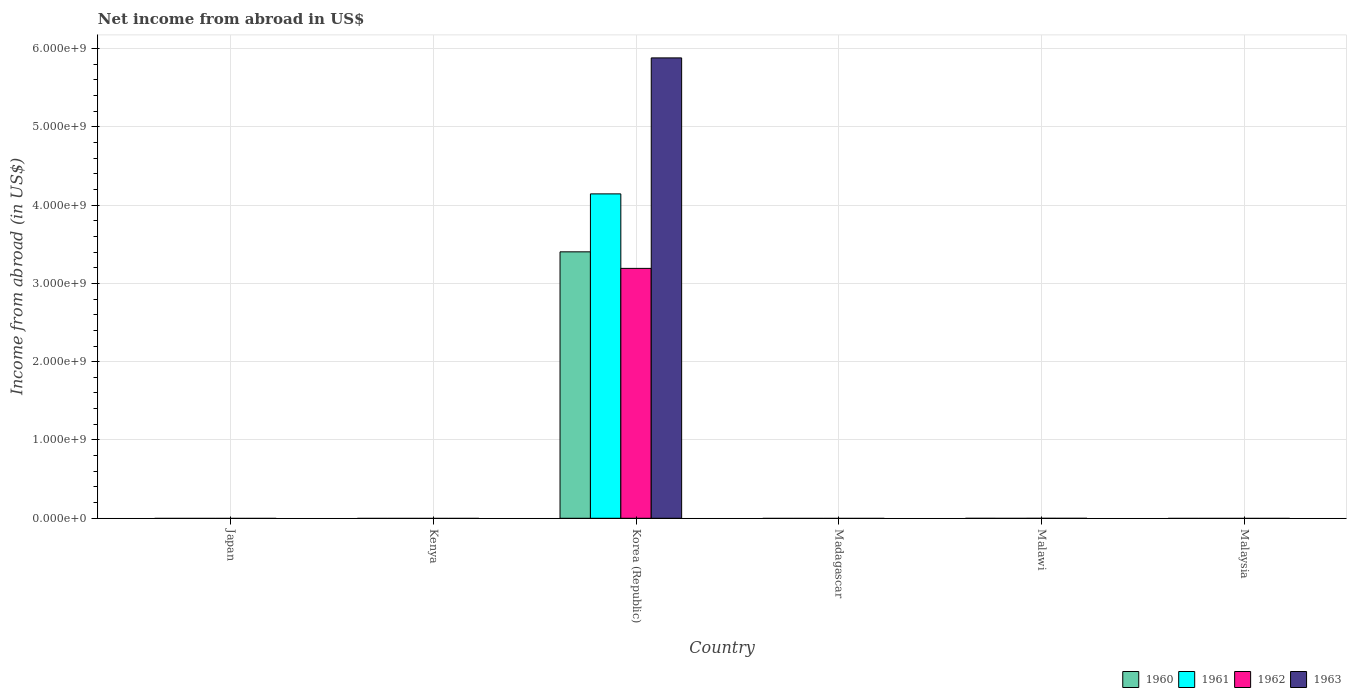How many different coloured bars are there?
Offer a terse response. 4. Are the number of bars on each tick of the X-axis equal?
Keep it short and to the point. No. How many bars are there on the 2nd tick from the left?
Your answer should be very brief. 0. How many bars are there on the 4th tick from the right?
Your response must be concise. 4. In how many cases, is the number of bars for a given country not equal to the number of legend labels?
Offer a very short reply. 5. What is the net income from abroad in 1961 in Madagascar?
Ensure brevity in your answer.  0. Across all countries, what is the maximum net income from abroad in 1961?
Your answer should be very brief. 4.14e+09. Across all countries, what is the minimum net income from abroad in 1960?
Your response must be concise. 0. What is the total net income from abroad in 1963 in the graph?
Offer a very short reply. 5.88e+09. What is the difference between the net income from abroad in 1962 in Japan and the net income from abroad in 1963 in Korea (Republic)?
Offer a terse response. -5.88e+09. What is the average net income from abroad in 1960 per country?
Your answer should be very brief. 5.67e+08. What is the difference between the net income from abroad of/in 1962 and net income from abroad of/in 1960 in Korea (Republic)?
Offer a terse response. -2.11e+08. In how many countries, is the net income from abroad in 1960 greater than 5400000000 US$?
Keep it short and to the point. 0. What is the difference between the highest and the lowest net income from abroad in 1960?
Ensure brevity in your answer.  3.40e+09. In how many countries, is the net income from abroad in 1960 greater than the average net income from abroad in 1960 taken over all countries?
Make the answer very short. 1. Does the graph contain grids?
Your answer should be compact. Yes. Where does the legend appear in the graph?
Provide a short and direct response. Bottom right. How many legend labels are there?
Offer a very short reply. 4. How are the legend labels stacked?
Your answer should be compact. Horizontal. What is the title of the graph?
Your response must be concise. Net income from abroad in US$. Does "2004" appear as one of the legend labels in the graph?
Keep it short and to the point. No. What is the label or title of the X-axis?
Your answer should be compact. Country. What is the label or title of the Y-axis?
Provide a short and direct response. Income from abroad (in US$). What is the Income from abroad (in US$) of 1960 in Japan?
Give a very brief answer. 0. What is the Income from abroad (in US$) in 1963 in Japan?
Offer a terse response. 0. What is the Income from abroad (in US$) in 1962 in Kenya?
Your answer should be compact. 0. What is the Income from abroad (in US$) of 1960 in Korea (Republic)?
Your answer should be very brief. 3.40e+09. What is the Income from abroad (in US$) in 1961 in Korea (Republic)?
Give a very brief answer. 4.14e+09. What is the Income from abroad (in US$) in 1962 in Korea (Republic)?
Give a very brief answer. 3.19e+09. What is the Income from abroad (in US$) of 1963 in Korea (Republic)?
Your response must be concise. 5.88e+09. What is the Income from abroad (in US$) in 1961 in Madagascar?
Make the answer very short. 0. What is the Income from abroad (in US$) in 1963 in Madagascar?
Offer a terse response. 0. What is the Income from abroad (in US$) of 1962 in Malawi?
Offer a terse response. 0. Across all countries, what is the maximum Income from abroad (in US$) in 1960?
Provide a short and direct response. 3.40e+09. Across all countries, what is the maximum Income from abroad (in US$) in 1961?
Your answer should be very brief. 4.14e+09. Across all countries, what is the maximum Income from abroad (in US$) in 1962?
Give a very brief answer. 3.19e+09. Across all countries, what is the maximum Income from abroad (in US$) in 1963?
Keep it short and to the point. 5.88e+09. Across all countries, what is the minimum Income from abroad (in US$) in 1960?
Provide a short and direct response. 0. Across all countries, what is the minimum Income from abroad (in US$) in 1961?
Provide a short and direct response. 0. What is the total Income from abroad (in US$) in 1960 in the graph?
Your answer should be compact. 3.40e+09. What is the total Income from abroad (in US$) in 1961 in the graph?
Provide a succinct answer. 4.14e+09. What is the total Income from abroad (in US$) in 1962 in the graph?
Offer a very short reply. 3.19e+09. What is the total Income from abroad (in US$) of 1963 in the graph?
Provide a succinct answer. 5.88e+09. What is the average Income from abroad (in US$) in 1960 per country?
Your answer should be very brief. 5.67e+08. What is the average Income from abroad (in US$) in 1961 per country?
Ensure brevity in your answer.  6.90e+08. What is the average Income from abroad (in US$) in 1962 per country?
Keep it short and to the point. 5.32e+08. What is the average Income from abroad (in US$) in 1963 per country?
Your answer should be compact. 9.80e+08. What is the difference between the Income from abroad (in US$) of 1960 and Income from abroad (in US$) of 1961 in Korea (Republic)?
Your response must be concise. -7.40e+08. What is the difference between the Income from abroad (in US$) of 1960 and Income from abroad (in US$) of 1962 in Korea (Republic)?
Give a very brief answer. 2.11e+08. What is the difference between the Income from abroad (in US$) of 1960 and Income from abroad (in US$) of 1963 in Korea (Republic)?
Provide a succinct answer. -2.48e+09. What is the difference between the Income from abroad (in US$) of 1961 and Income from abroad (in US$) of 1962 in Korea (Republic)?
Offer a very short reply. 9.52e+08. What is the difference between the Income from abroad (in US$) of 1961 and Income from abroad (in US$) of 1963 in Korea (Republic)?
Give a very brief answer. -1.74e+09. What is the difference between the Income from abroad (in US$) of 1962 and Income from abroad (in US$) of 1963 in Korea (Republic)?
Your response must be concise. -2.69e+09. What is the difference between the highest and the lowest Income from abroad (in US$) in 1960?
Keep it short and to the point. 3.40e+09. What is the difference between the highest and the lowest Income from abroad (in US$) in 1961?
Make the answer very short. 4.14e+09. What is the difference between the highest and the lowest Income from abroad (in US$) in 1962?
Your response must be concise. 3.19e+09. What is the difference between the highest and the lowest Income from abroad (in US$) of 1963?
Offer a terse response. 5.88e+09. 